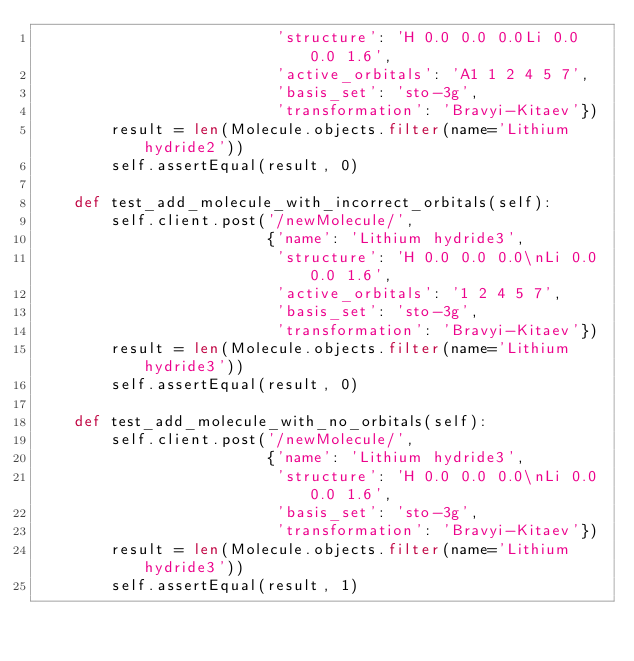Convert code to text. <code><loc_0><loc_0><loc_500><loc_500><_Python_>                          'structure': 'H 0.0 0.0 0.0Li 0.0 0.0 1.6',
                          'active_orbitals': 'A1 1 2 4 5 7',
                          'basis_set': 'sto-3g',
                          'transformation': 'Bravyi-Kitaev'})
        result = len(Molecule.objects.filter(name='Lithium hydride2'))
        self.assertEqual(result, 0)

    def test_add_molecule_with_incorrect_orbitals(self):
        self.client.post('/newMolecule/',
                         {'name': 'Lithium hydride3',
                          'structure': 'H 0.0 0.0 0.0\nLi 0.0 0.0 1.6',
                          'active_orbitals': '1 2 4 5 7',
                          'basis_set': 'sto-3g',
                          'transformation': 'Bravyi-Kitaev'})
        result = len(Molecule.objects.filter(name='Lithium hydride3'))
        self.assertEqual(result, 0)

    def test_add_molecule_with_no_orbitals(self):
        self.client.post('/newMolecule/',
                         {'name': 'Lithium hydride3',
                          'structure': 'H 0.0 0.0 0.0\nLi 0.0 0.0 1.6',
                          'basis_set': 'sto-3g',
                          'transformation': 'Bravyi-Kitaev'})
        result = len(Molecule.objects.filter(name='Lithium hydride3'))
        self.assertEqual(result, 1)
</code> 